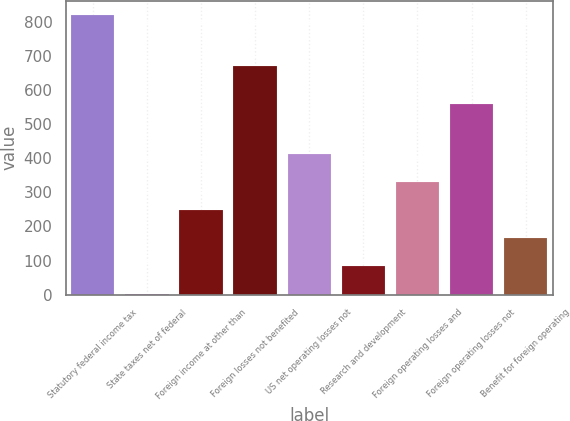Convert chart. <chart><loc_0><loc_0><loc_500><loc_500><bar_chart><fcel>Statutory federal income tax<fcel>State taxes net of federal<fcel>Foreign income at other than<fcel>Foreign losses not benefited<fcel>US net operating losses not<fcel>Research and development<fcel>Foreign operating losses and<fcel>Foreign operating losses not<fcel>Benefit for foreign operating<nl><fcel>821<fcel>1<fcel>247<fcel>670<fcel>411<fcel>83<fcel>329<fcel>558<fcel>165<nl></chart> 